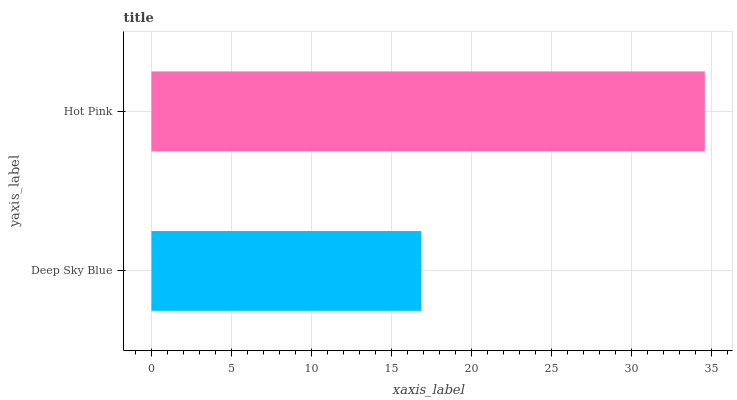Is Deep Sky Blue the minimum?
Answer yes or no. Yes. Is Hot Pink the maximum?
Answer yes or no. Yes. Is Hot Pink the minimum?
Answer yes or no. No. Is Hot Pink greater than Deep Sky Blue?
Answer yes or no. Yes. Is Deep Sky Blue less than Hot Pink?
Answer yes or no. Yes. Is Deep Sky Blue greater than Hot Pink?
Answer yes or no. No. Is Hot Pink less than Deep Sky Blue?
Answer yes or no. No. Is Hot Pink the high median?
Answer yes or no. Yes. Is Deep Sky Blue the low median?
Answer yes or no. Yes. Is Deep Sky Blue the high median?
Answer yes or no. No. Is Hot Pink the low median?
Answer yes or no. No. 